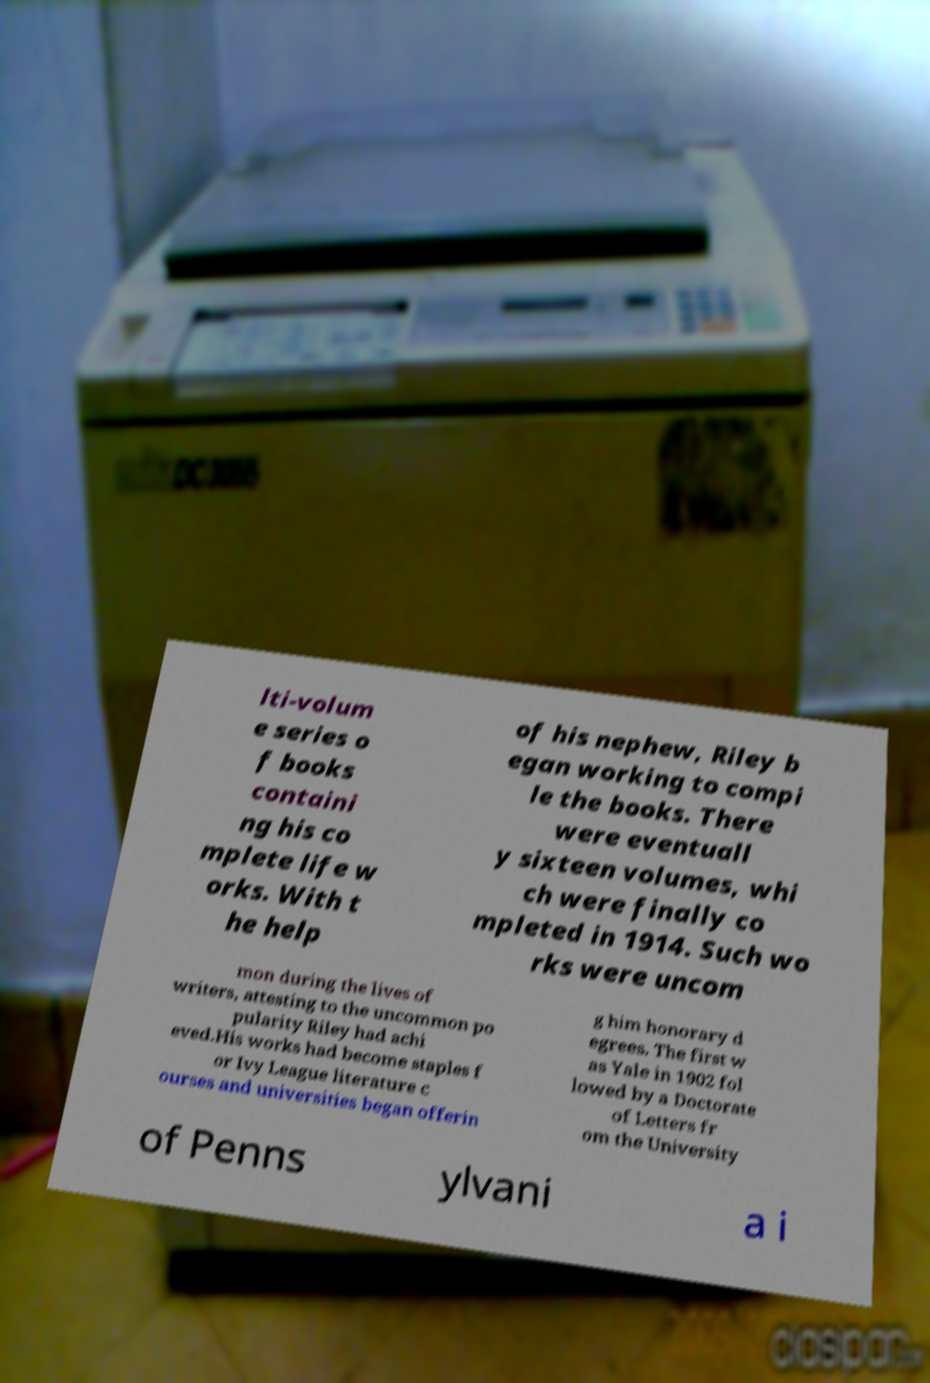Can you read and provide the text displayed in the image?This photo seems to have some interesting text. Can you extract and type it out for me? lti-volum e series o f books containi ng his co mplete life w orks. With t he help of his nephew, Riley b egan working to compi le the books. There were eventuall y sixteen volumes, whi ch were finally co mpleted in 1914. Such wo rks were uncom mon during the lives of writers, attesting to the uncommon po pularity Riley had achi eved.His works had become staples f or Ivy League literature c ourses and universities began offerin g him honorary d egrees. The first w as Yale in 1902 fol lowed by a Doctorate of Letters fr om the University of Penns ylvani a i 